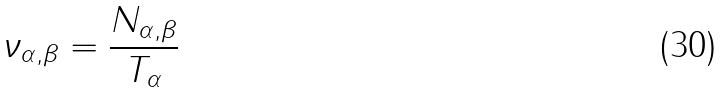<formula> <loc_0><loc_0><loc_500><loc_500>\nu _ { \alpha , \beta } = \frac { N _ { \alpha , \beta } } { T _ { \alpha } }</formula> 